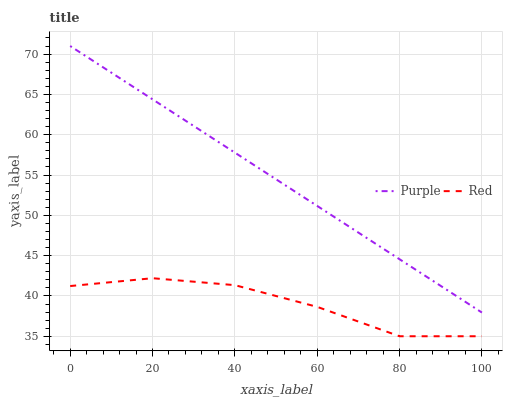Does Red have the maximum area under the curve?
Answer yes or no. No. Is Red the smoothest?
Answer yes or no. No. Does Red have the highest value?
Answer yes or no. No. Is Red less than Purple?
Answer yes or no. Yes. Is Purple greater than Red?
Answer yes or no. Yes. Does Red intersect Purple?
Answer yes or no. No. 